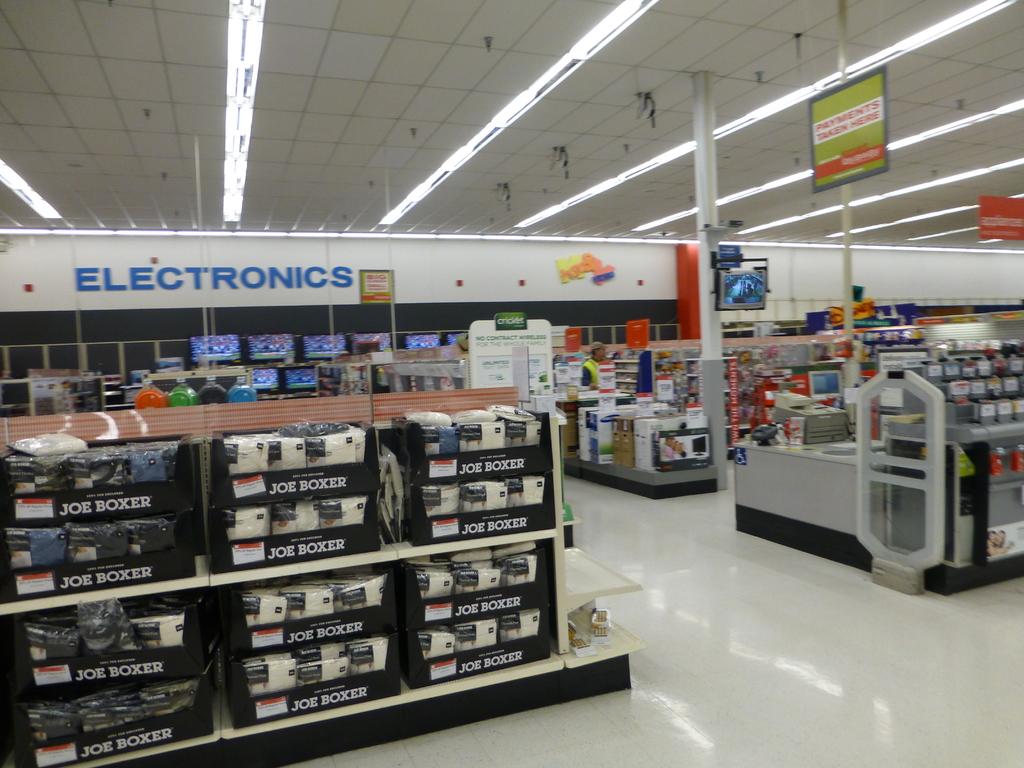What section of the store is shown?
Provide a short and direct response. Electronics. What items are in this section of the store?
Offer a terse response. Electronics. 